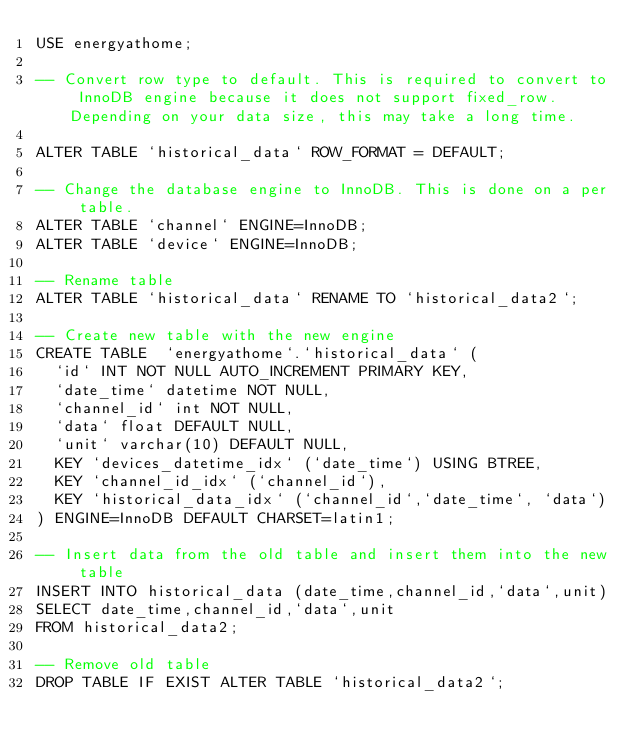Convert code to text. <code><loc_0><loc_0><loc_500><loc_500><_SQL_>USE energyathome;

-- Convert row type to default. This is required to convert to InnoDB engine because it does not support fixed_row. Depending on your data size, this may take a long time.

ALTER TABLE `historical_data` ROW_FORMAT = DEFAULT;

-- Change the database engine to InnoDB. This is done on a per table.
ALTER TABLE `channel` ENGINE=InnoDB;
ALTER TABLE `device` ENGINE=InnoDB;

-- Rename table
ALTER TABLE `historical_data` RENAME TO `historical_data2`;

-- Create new table with the new engine
CREATE TABLE  `energyathome`.`historical_data` (
  `id` INT NOT NULL AUTO_INCREMENT PRIMARY KEY,
  `date_time` datetime NOT NULL,
  `channel_id` int NOT NULL,
  `data` float DEFAULT NULL,
  `unit` varchar(10) DEFAULT NULL,
  KEY `devices_datetime_idx` (`date_time`) USING BTREE,
  KEY `channel_id_idx` (`channel_id`),
  KEY `historical_data_idx` (`channel_id`,`date_time`, `data`)
) ENGINE=InnoDB DEFAULT CHARSET=latin1;

-- Insert data from the old table and insert them into the new table
INSERT INTO historical_data (date_time,channel_id,`data`,unit)
SELECT date_time,channel_id,`data`,unit
FROM historical_data2;

-- Remove old table
DROP TABLE IF EXIST ALTER TABLE `historical_data2`;
</code> 